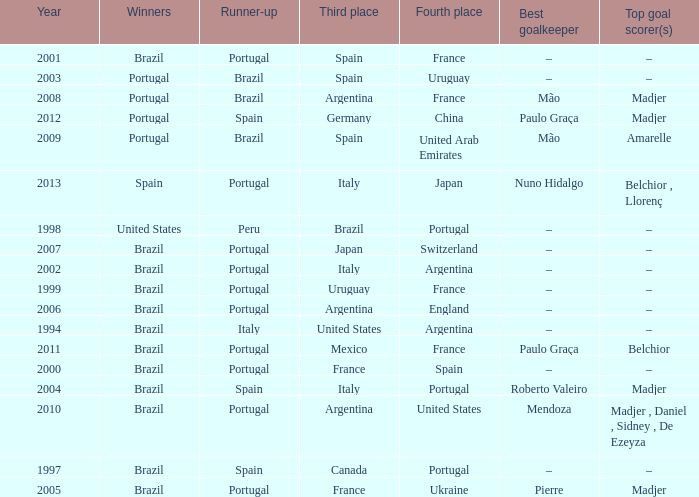What year was the runner-up Portugal with Italy in third place, and the gold keeper Nuno Hidalgo? 2013.0. 